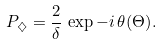Convert formula to latex. <formula><loc_0><loc_0><loc_500><loc_500>P _ { \diamondsuit } = \frac { 2 } { \delta } \, \exp { - i \, \theta ( \Theta ) } .</formula> 